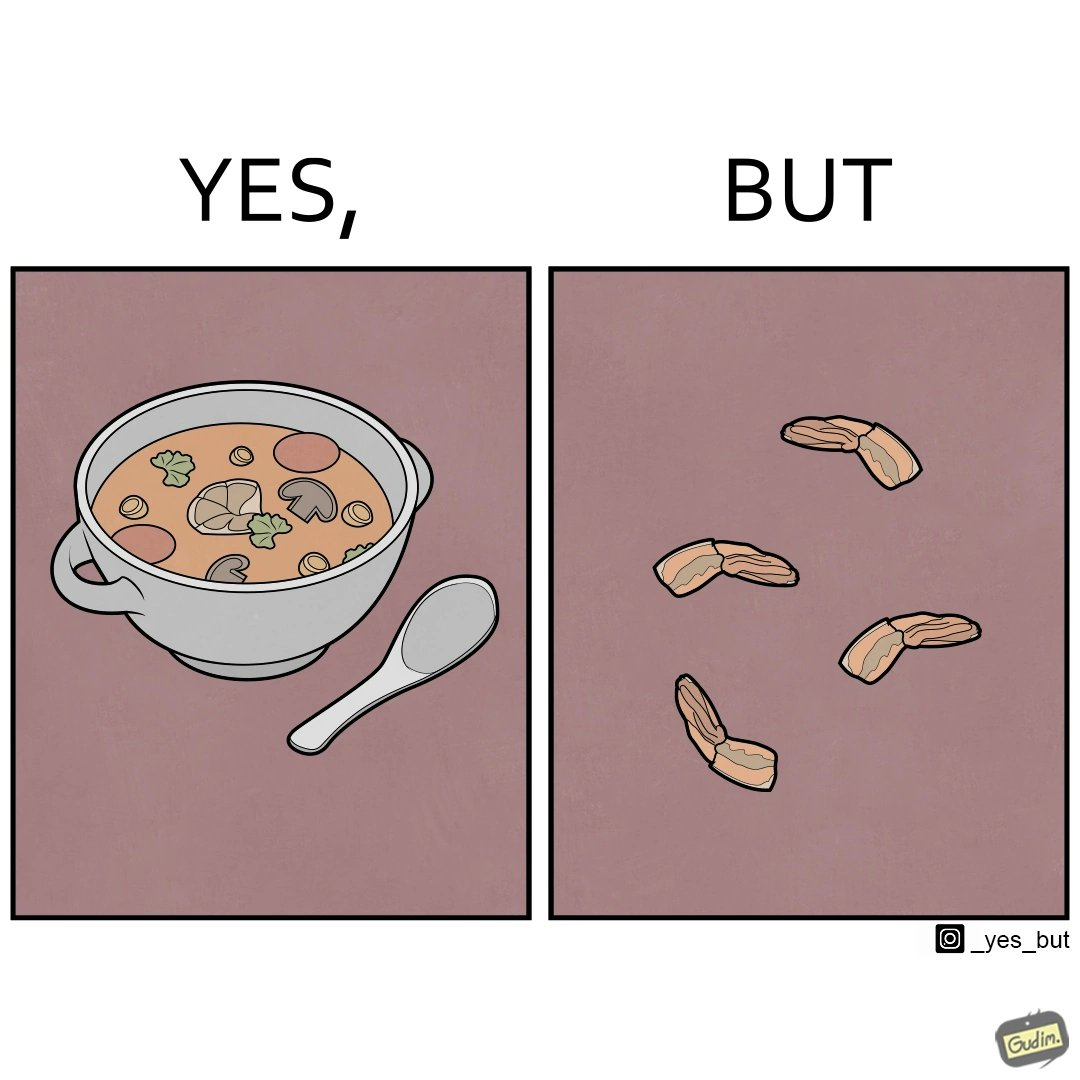Provide a description of this image. when we drink the whole soup, then  it is very healthy. But people eliminate some things which they don't like. 